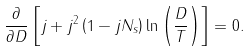<formula> <loc_0><loc_0><loc_500><loc_500>\frac { \partial } { \partial D } \left [ j + j ^ { 2 } \left ( 1 - j N _ { s } \right ) \ln \left ( \frac { D } { T } \right ) \right ] = 0 .</formula> 